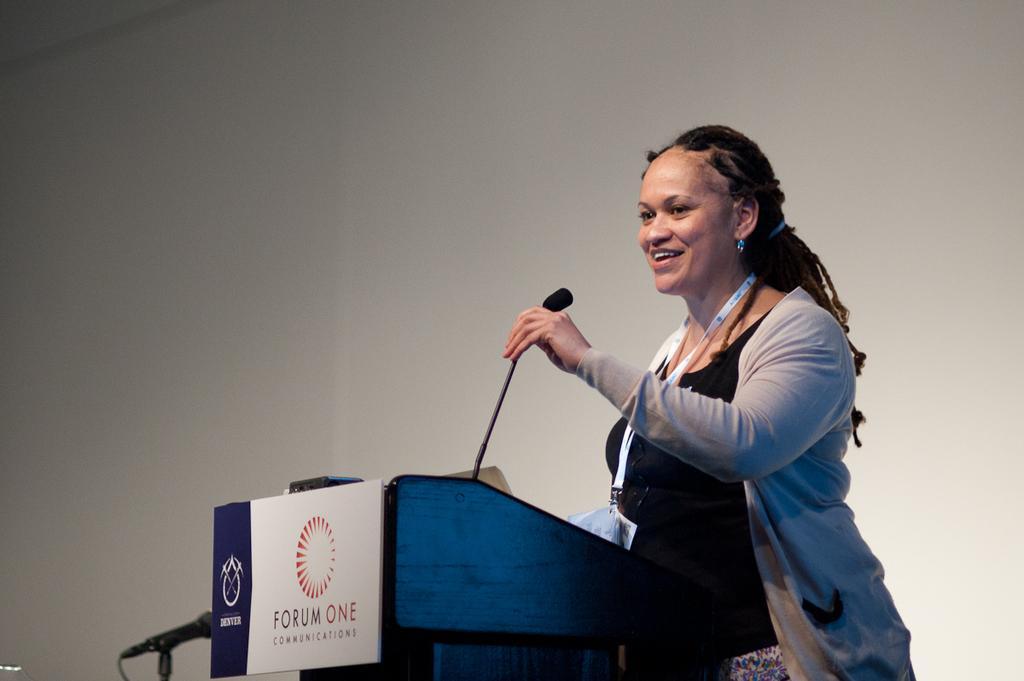Please provide a concise description of this image. Here we can see a woman standing near a speech desk with a microphone in her hand 